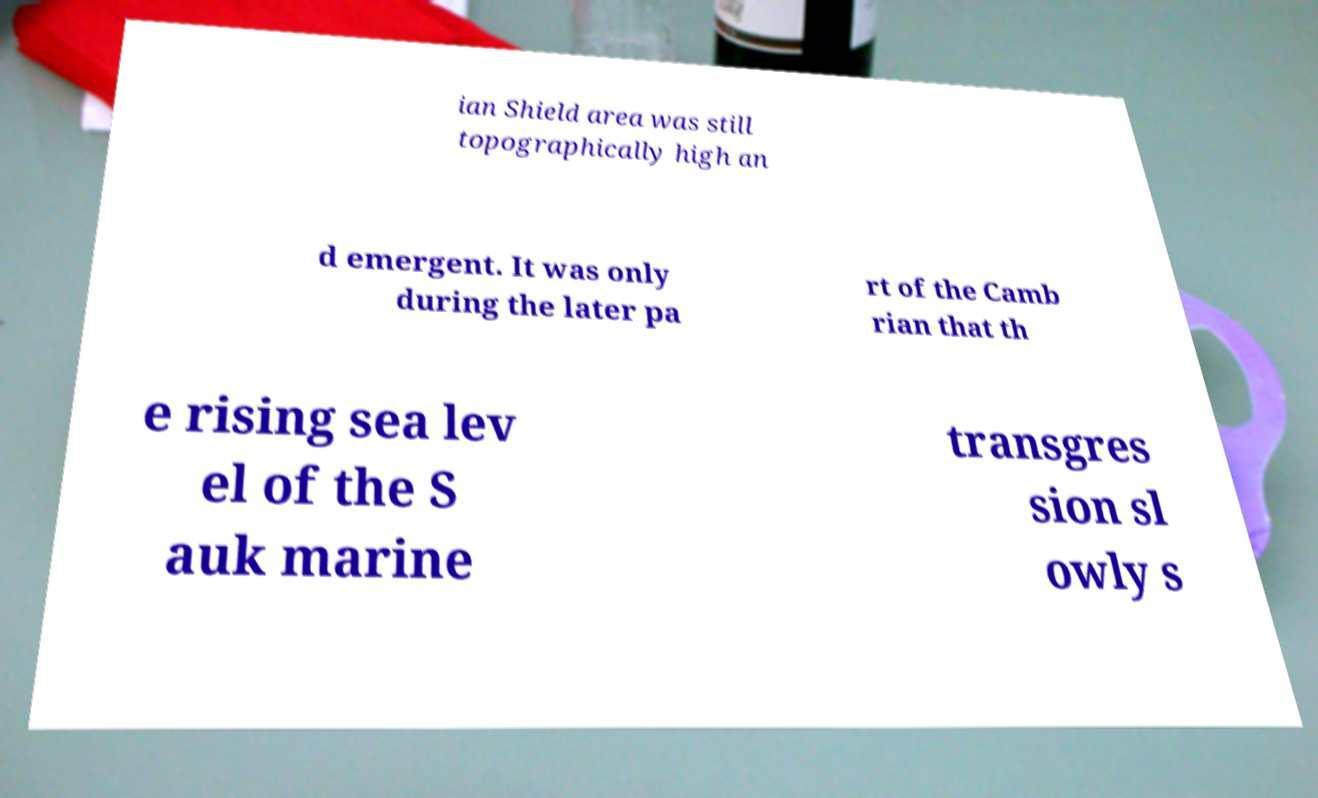What messages or text are displayed in this image? I need them in a readable, typed format. ian Shield area was still topographically high an d emergent. It was only during the later pa rt of the Camb rian that th e rising sea lev el of the S auk marine transgres sion sl owly s 